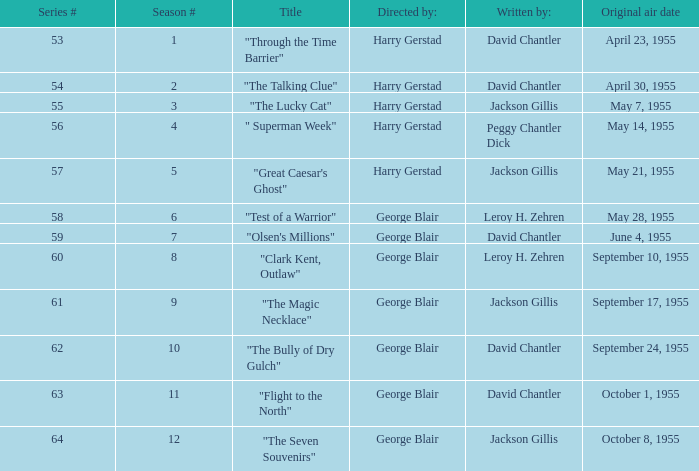Who directed the episode that was written by Jackson Gillis and Originally aired on May 21, 1955? Harry Gerstad. 